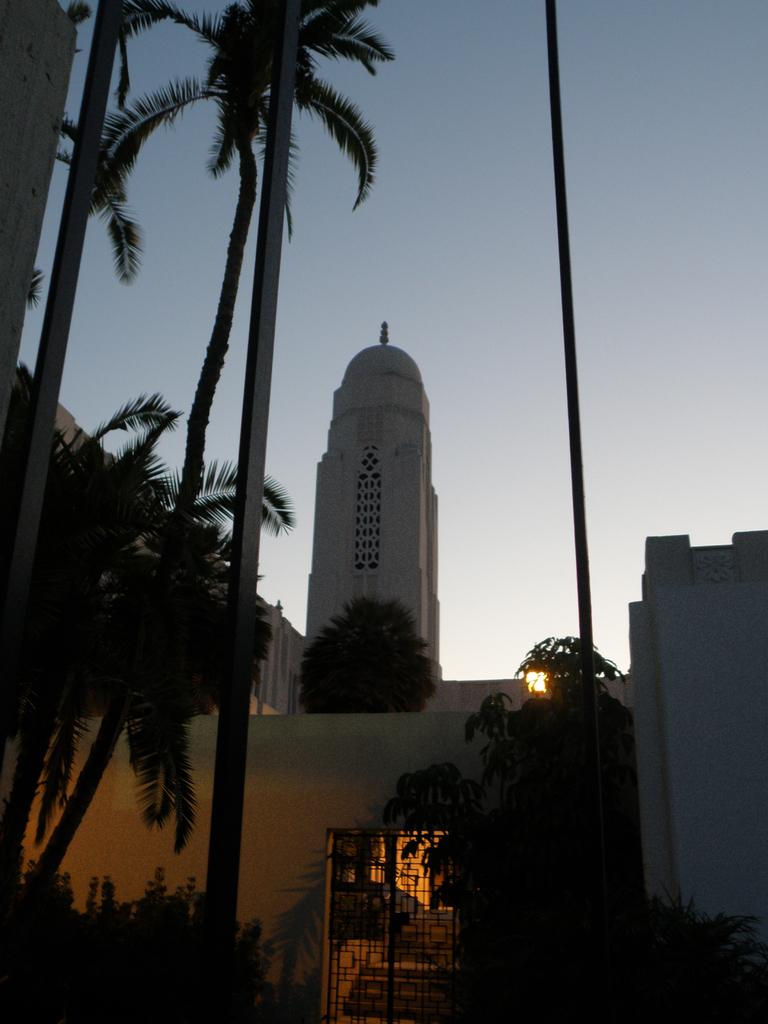What type of vegetation can be seen in the image? There are trees and plants in the image. What structures are present in the image? There are poles, buildings, and a gate in the image. What else can be seen in the image besides the vegetation and structures? There are objects in the image. What is visible in the background of the image? The sky is visible in the image. What type of force can be seen affecting the trees in the image? There is no force affecting the trees in the image; they are stationary. Can you describe the fog in the image? There is no fog present in the image. 